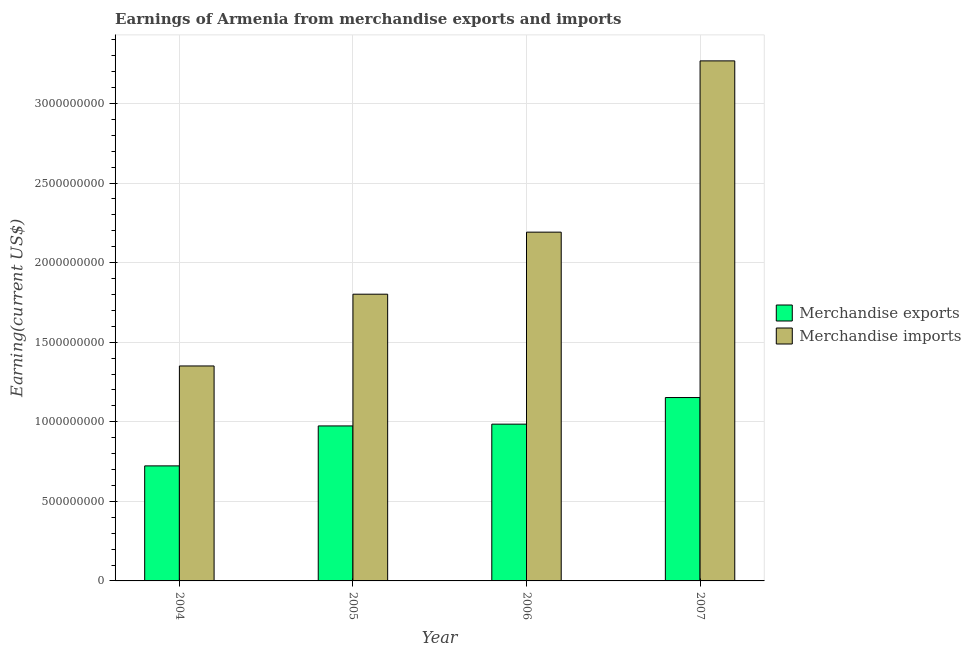Are the number of bars per tick equal to the number of legend labels?
Your answer should be very brief. Yes. What is the earnings from merchandise exports in 2005?
Your answer should be very brief. 9.74e+08. Across all years, what is the maximum earnings from merchandise exports?
Ensure brevity in your answer.  1.15e+09. Across all years, what is the minimum earnings from merchandise exports?
Your answer should be very brief. 7.23e+08. What is the total earnings from merchandise exports in the graph?
Your response must be concise. 3.83e+09. What is the difference between the earnings from merchandise imports in 2004 and that in 2005?
Provide a succinct answer. -4.51e+08. What is the difference between the earnings from merchandise imports in 2004 and the earnings from merchandise exports in 2007?
Your answer should be compact. -1.92e+09. What is the average earnings from merchandise exports per year?
Offer a very short reply. 9.59e+08. In the year 2006, what is the difference between the earnings from merchandise exports and earnings from merchandise imports?
Provide a succinct answer. 0. What is the ratio of the earnings from merchandise imports in 2004 to that in 2005?
Give a very brief answer. 0.75. What is the difference between the highest and the second highest earnings from merchandise exports?
Your answer should be very brief. 1.67e+08. What is the difference between the highest and the lowest earnings from merchandise imports?
Offer a very short reply. 1.92e+09. Are all the bars in the graph horizontal?
Give a very brief answer. No. How many years are there in the graph?
Give a very brief answer. 4. Are the values on the major ticks of Y-axis written in scientific E-notation?
Provide a succinct answer. No. Does the graph contain any zero values?
Your response must be concise. No. Where does the legend appear in the graph?
Give a very brief answer. Center right. How many legend labels are there?
Offer a very short reply. 2. How are the legend labels stacked?
Keep it short and to the point. Vertical. What is the title of the graph?
Provide a short and direct response. Earnings of Armenia from merchandise exports and imports. Does "Investment in Telecom" appear as one of the legend labels in the graph?
Provide a succinct answer. No. What is the label or title of the Y-axis?
Make the answer very short. Earning(current US$). What is the Earning(current US$) of Merchandise exports in 2004?
Your answer should be very brief. 7.23e+08. What is the Earning(current US$) in Merchandise imports in 2004?
Keep it short and to the point. 1.35e+09. What is the Earning(current US$) in Merchandise exports in 2005?
Your response must be concise. 9.74e+08. What is the Earning(current US$) in Merchandise imports in 2005?
Your answer should be compact. 1.80e+09. What is the Earning(current US$) in Merchandise exports in 2006?
Keep it short and to the point. 9.85e+08. What is the Earning(current US$) of Merchandise imports in 2006?
Provide a succinct answer. 2.19e+09. What is the Earning(current US$) of Merchandise exports in 2007?
Make the answer very short. 1.15e+09. What is the Earning(current US$) in Merchandise imports in 2007?
Your answer should be very brief. 3.27e+09. Across all years, what is the maximum Earning(current US$) of Merchandise exports?
Keep it short and to the point. 1.15e+09. Across all years, what is the maximum Earning(current US$) in Merchandise imports?
Provide a succinct answer. 3.27e+09. Across all years, what is the minimum Earning(current US$) of Merchandise exports?
Offer a terse response. 7.23e+08. Across all years, what is the minimum Earning(current US$) in Merchandise imports?
Your answer should be compact. 1.35e+09. What is the total Earning(current US$) of Merchandise exports in the graph?
Give a very brief answer. 3.83e+09. What is the total Earning(current US$) of Merchandise imports in the graph?
Your answer should be very brief. 8.61e+09. What is the difference between the Earning(current US$) of Merchandise exports in 2004 and that in 2005?
Keep it short and to the point. -2.51e+08. What is the difference between the Earning(current US$) in Merchandise imports in 2004 and that in 2005?
Offer a terse response. -4.51e+08. What is the difference between the Earning(current US$) of Merchandise exports in 2004 and that in 2006?
Offer a very short reply. -2.62e+08. What is the difference between the Earning(current US$) in Merchandise imports in 2004 and that in 2006?
Your answer should be compact. -8.41e+08. What is the difference between the Earning(current US$) in Merchandise exports in 2004 and that in 2007?
Offer a terse response. -4.29e+08. What is the difference between the Earning(current US$) of Merchandise imports in 2004 and that in 2007?
Provide a short and direct response. -1.92e+09. What is the difference between the Earning(current US$) in Merchandise exports in 2005 and that in 2006?
Provide a succinct answer. -1.12e+07. What is the difference between the Earning(current US$) in Merchandise imports in 2005 and that in 2006?
Your response must be concise. -3.90e+08. What is the difference between the Earning(current US$) in Merchandise exports in 2005 and that in 2007?
Your response must be concise. -1.78e+08. What is the difference between the Earning(current US$) in Merchandise imports in 2005 and that in 2007?
Keep it short and to the point. -1.47e+09. What is the difference between the Earning(current US$) in Merchandise exports in 2006 and that in 2007?
Offer a terse response. -1.67e+08. What is the difference between the Earning(current US$) in Merchandise imports in 2006 and that in 2007?
Your answer should be compact. -1.08e+09. What is the difference between the Earning(current US$) of Merchandise exports in 2004 and the Earning(current US$) of Merchandise imports in 2005?
Your response must be concise. -1.08e+09. What is the difference between the Earning(current US$) in Merchandise exports in 2004 and the Earning(current US$) in Merchandise imports in 2006?
Ensure brevity in your answer.  -1.47e+09. What is the difference between the Earning(current US$) in Merchandise exports in 2004 and the Earning(current US$) in Merchandise imports in 2007?
Your response must be concise. -2.54e+09. What is the difference between the Earning(current US$) of Merchandise exports in 2005 and the Earning(current US$) of Merchandise imports in 2006?
Make the answer very short. -1.22e+09. What is the difference between the Earning(current US$) of Merchandise exports in 2005 and the Earning(current US$) of Merchandise imports in 2007?
Give a very brief answer. -2.29e+09. What is the difference between the Earning(current US$) in Merchandise exports in 2006 and the Earning(current US$) in Merchandise imports in 2007?
Offer a terse response. -2.28e+09. What is the average Earning(current US$) of Merchandise exports per year?
Keep it short and to the point. 9.59e+08. What is the average Earning(current US$) of Merchandise imports per year?
Ensure brevity in your answer.  2.15e+09. In the year 2004, what is the difference between the Earning(current US$) of Merchandise exports and Earning(current US$) of Merchandise imports?
Offer a terse response. -6.28e+08. In the year 2005, what is the difference between the Earning(current US$) of Merchandise exports and Earning(current US$) of Merchandise imports?
Provide a succinct answer. -8.28e+08. In the year 2006, what is the difference between the Earning(current US$) of Merchandise exports and Earning(current US$) of Merchandise imports?
Provide a short and direct response. -1.21e+09. In the year 2007, what is the difference between the Earning(current US$) of Merchandise exports and Earning(current US$) of Merchandise imports?
Keep it short and to the point. -2.12e+09. What is the ratio of the Earning(current US$) in Merchandise exports in 2004 to that in 2005?
Ensure brevity in your answer.  0.74. What is the ratio of the Earning(current US$) of Merchandise imports in 2004 to that in 2005?
Make the answer very short. 0.75. What is the ratio of the Earning(current US$) in Merchandise exports in 2004 to that in 2006?
Your answer should be compact. 0.73. What is the ratio of the Earning(current US$) of Merchandise imports in 2004 to that in 2006?
Ensure brevity in your answer.  0.62. What is the ratio of the Earning(current US$) of Merchandise exports in 2004 to that in 2007?
Provide a succinct answer. 0.63. What is the ratio of the Earning(current US$) of Merchandise imports in 2004 to that in 2007?
Offer a terse response. 0.41. What is the ratio of the Earning(current US$) of Merchandise exports in 2005 to that in 2006?
Make the answer very short. 0.99. What is the ratio of the Earning(current US$) of Merchandise imports in 2005 to that in 2006?
Your response must be concise. 0.82. What is the ratio of the Earning(current US$) in Merchandise exports in 2005 to that in 2007?
Your answer should be very brief. 0.85. What is the ratio of the Earning(current US$) of Merchandise imports in 2005 to that in 2007?
Offer a very short reply. 0.55. What is the ratio of the Earning(current US$) in Merchandise exports in 2006 to that in 2007?
Provide a short and direct response. 0.85. What is the ratio of the Earning(current US$) in Merchandise imports in 2006 to that in 2007?
Your response must be concise. 0.67. What is the difference between the highest and the second highest Earning(current US$) in Merchandise exports?
Keep it short and to the point. 1.67e+08. What is the difference between the highest and the second highest Earning(current US$) in Merchandise imports?
Make the answer very short. 1.08e+09. What is the difference between the highest and the lowest Earning(current US$) of Merchandise exports?
Ensure brevity in your answer.  4.29e+08. What is the difference between the highest and the lowest Earning(current US$) of Merchandise imports?
Offer a terse response. 1.92e+09. 